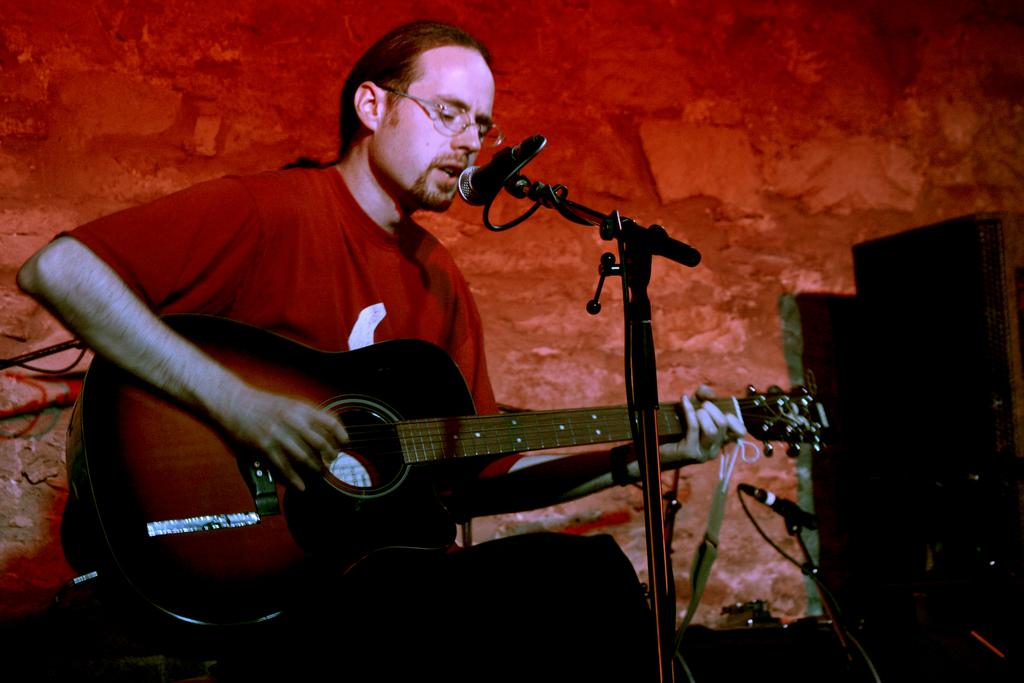What is the man in the image holding? The man is holding a guitar. What activity is the man engaged in? The man is singing on a microphone. What type of bucket can be seen in the image? There is no bucket present in the image. What time of day is it in the image? The time of day cannot be determined from the image. How many breaths can be heard from the man in the image? The number of breaths cannot be determined from the image, as it only shows a still picture. 